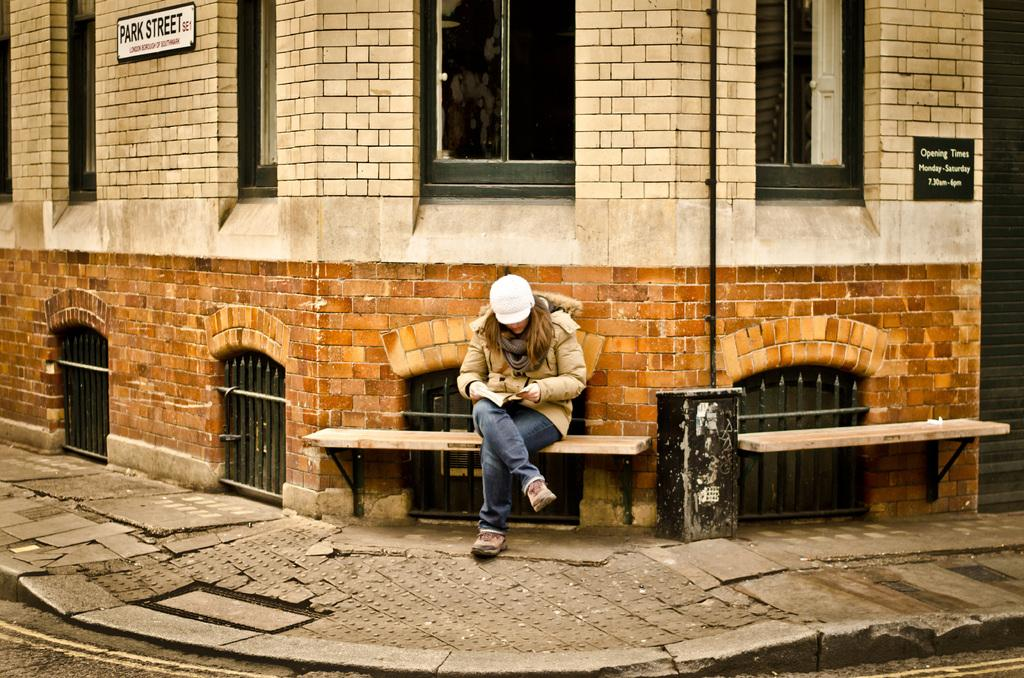What is the woman in the image doing? The woman is sitting on a bench in the image. What material is the wall behind the bench made of? The wall behind the bench is made of bricks. Can you describe any architectural features in the image? There is a window in the image, and the presence of a wall suggests there is a building. What is the woman's sister's belief about the expert in the image? There is no expert or sister present in the image, so it is not possible to answer that question. 